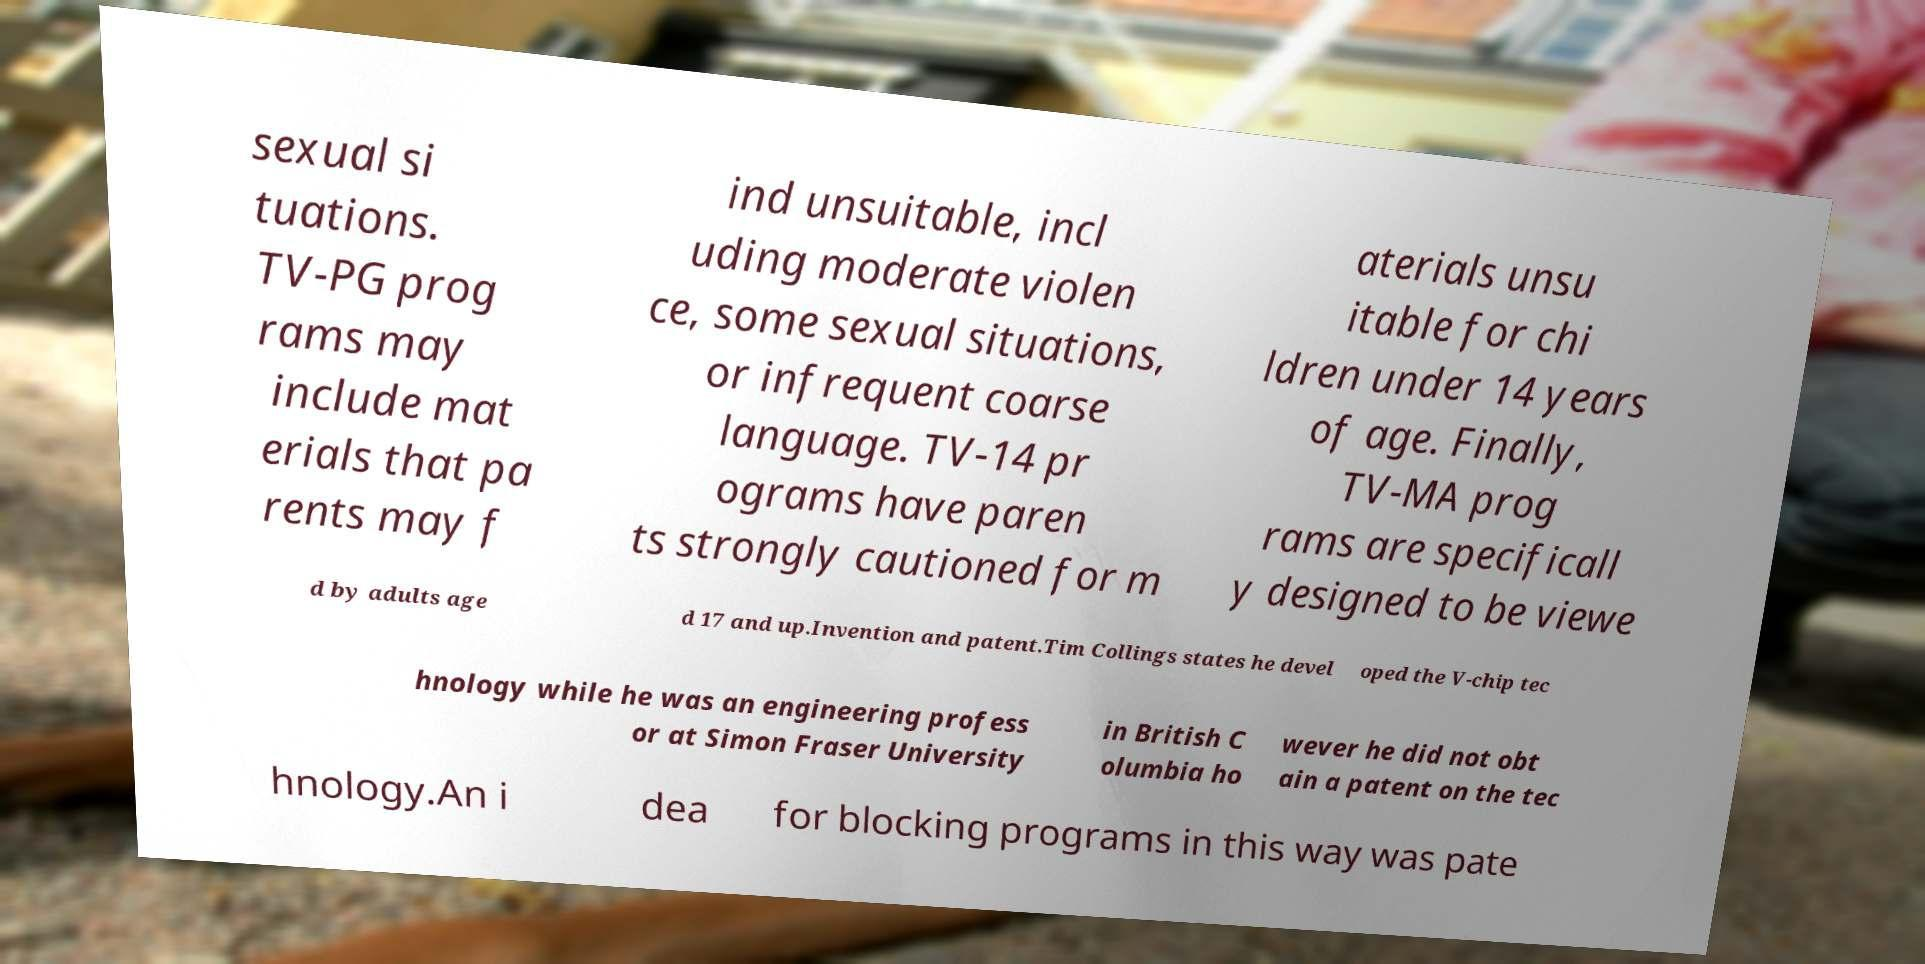Could you assist in decoding the text presented in this image and type it out clearly? sexual si tuations. TV-PG prog rams may include mat erials that pa rents may f ind unsuitable, incl uding moderate violen ce, some sexual situations, or infrequent coarse language. TV-14 pr ograms have paren ts strongly cautioned for m aterials unsu itable for chi ldren under 14 years of age. Finally, TV-MA prog rams are specificall y designed to be viewe d by adults age d 17 and up.Invention and patent.Tim Collings states he devel oped the V-chip tec hnology while he was an engineering profess or at Simon Fraser University in British C olumbia ho wever he did not obt ain a patent on the tec hnology.An i dea for blocking programs in this way was pate 